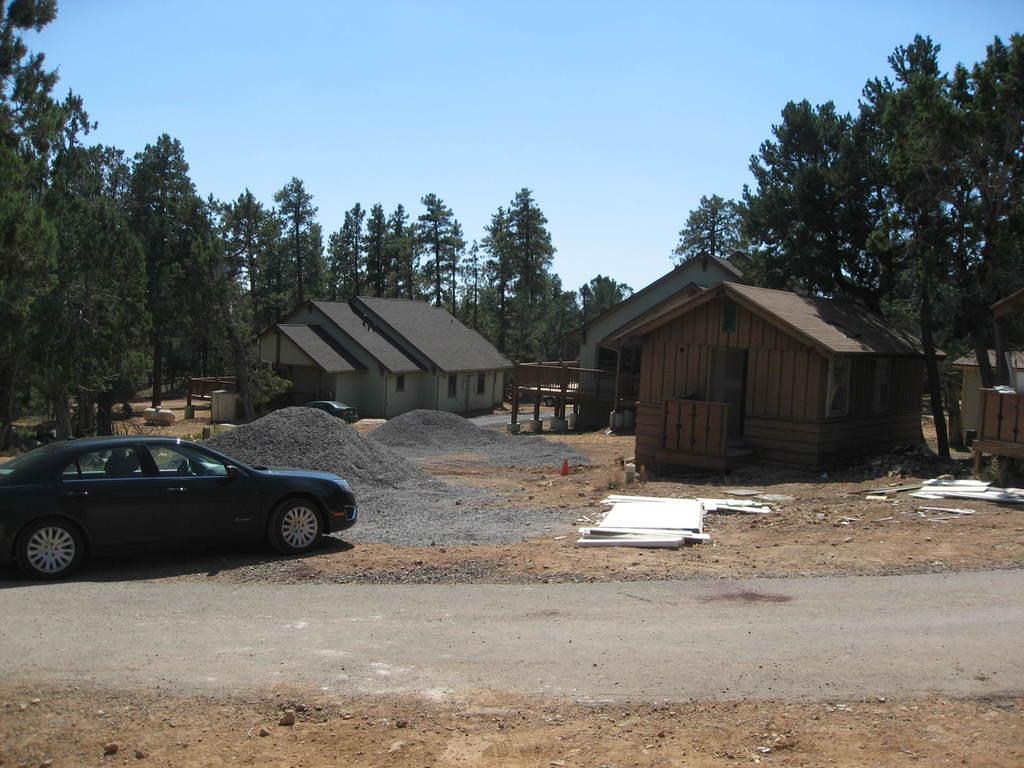Describe this image in one or two sentences. In this image there is the sky towards the top of the image, there are trees, there are houses, there are cars, there is road, there is ground towards the bottom of the image, there are objects on the ground. 